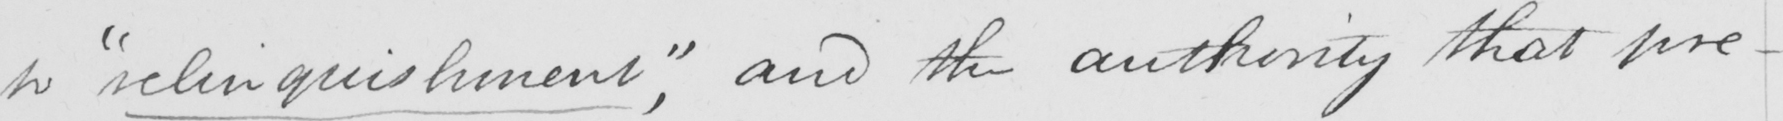Please transcribe the handwritten text in this image. to  " relinquishment "  , and the authority that pre- 